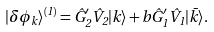<formula> <loc_0><loc_0><loc_500><loc_500>| \delta \phi _ { k } \rangle ^ { ( 1 ) } = \hat { G } _ { 2 } ^ { \prime } \hat { V } _ { 2 } | k \rangle + b \hat { G } _ { 1 } ^ { \prime } \hat { V } _ { 1 } | \bar { k } \rangle .</formula> 